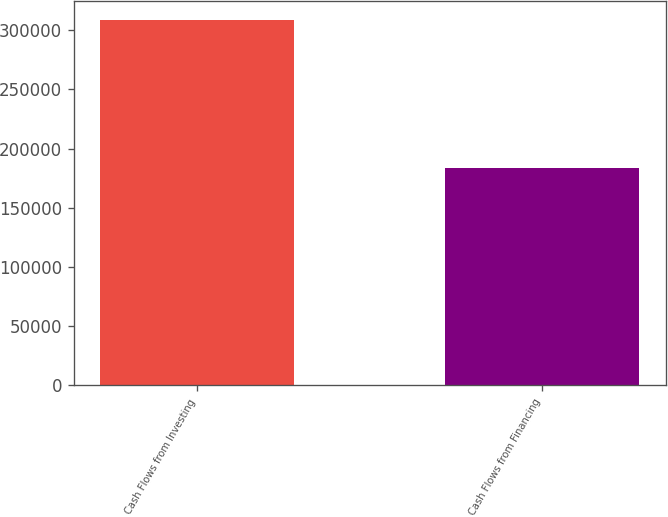<chart> <loc_0><loc_0><loc_500><loc_500><bar_chart><fcel>Cash Flows from Investing<fcel>Cash Flows from Financing<nl><fcel>308743<fcel>183564<nl></chart> 